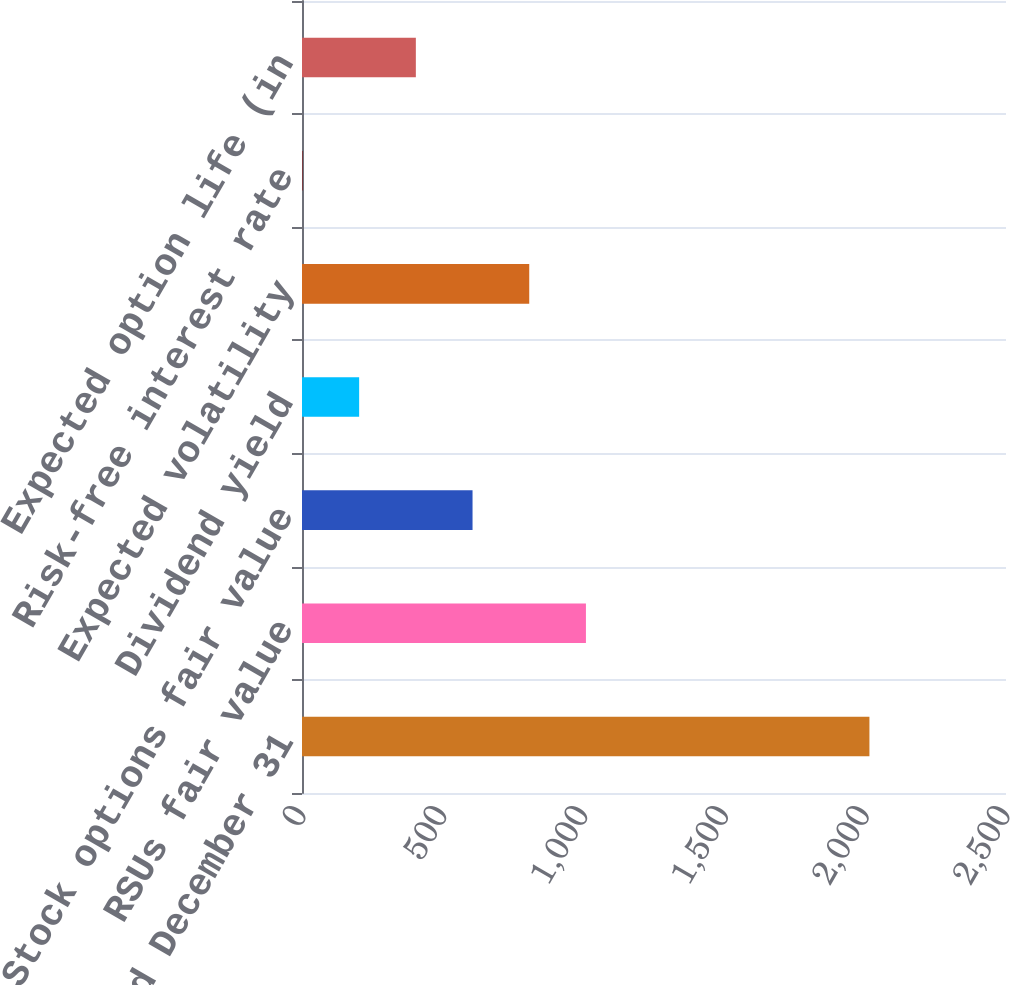<chart> <loc_0><loc_0><loc_500><loc_500><bar_chart><fcel>Year ended December 31<fcel>RSUs fair value<fcel>Stock options fair value<fcel>Dividend yield<fcel>Expected volatility<fcel>Risk-free interest rate<fcel>Expected option life (in<nl><fcel>2015<fcel>1008.3<fcel>605.62<fcel>202.94<fcel>806.96<fcel>1.6<fcel>404.28<nl></chart> 